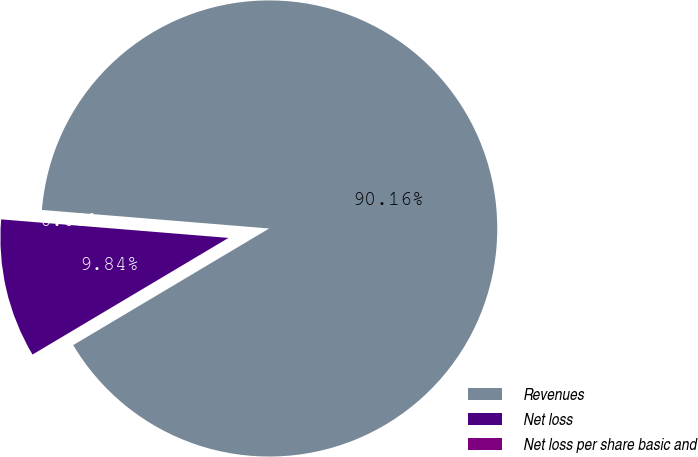Convert chart. <chart><loc_0><loc_0><loc_500><loc_500><pie_chart><fcel>Revenues<fcel>Net loss<fcel>Net loss per share basic and<nl><fcel>90.16%<fcel>9.84%<fcel>0.0%<nl></chart> 